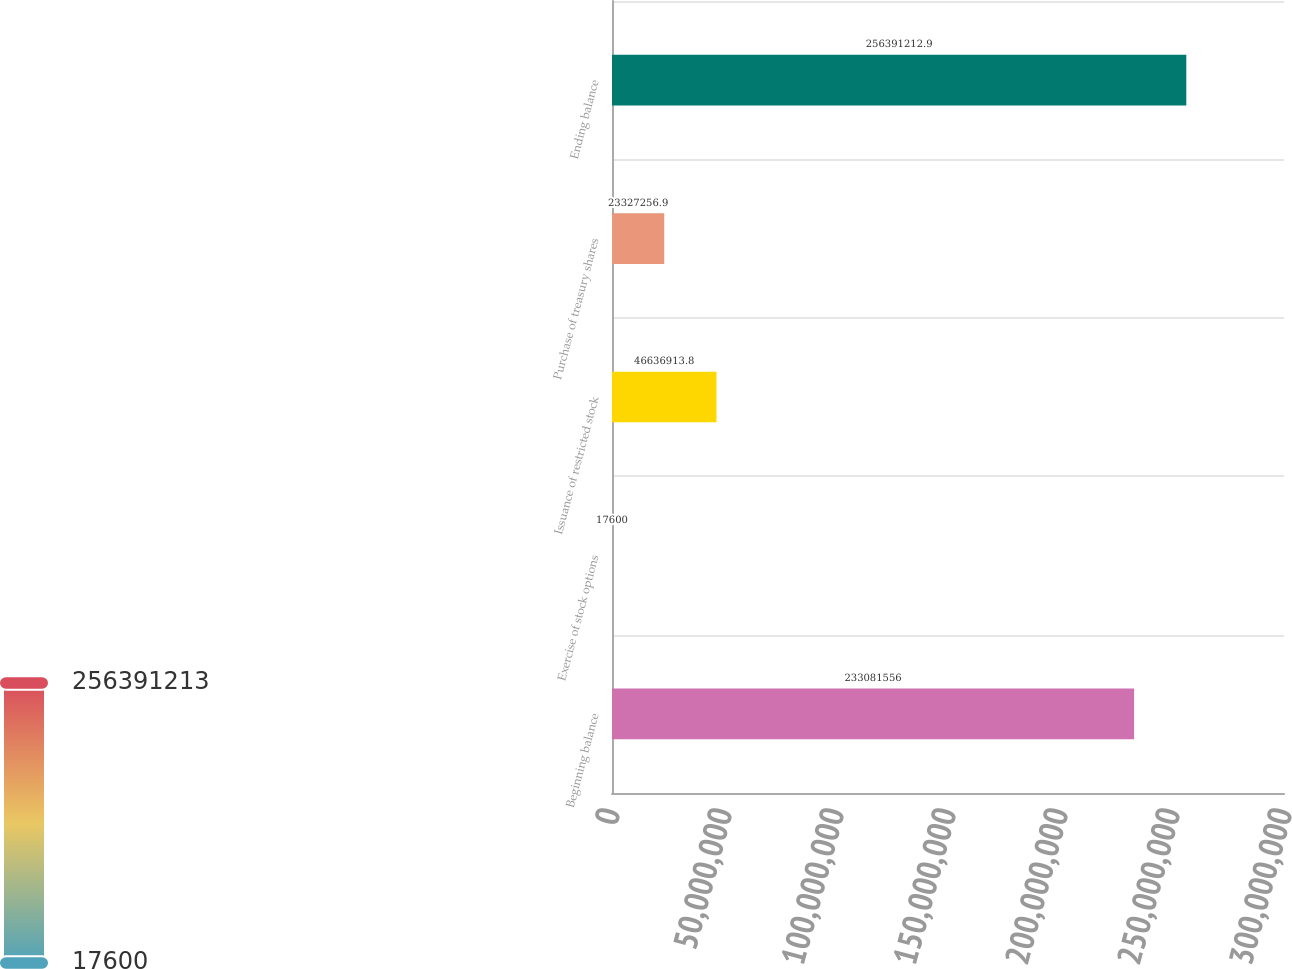Convert chart. <chart><loc_0><loc_0><loc_500><loc_500><bar_chart><fcel>Beginning balance<fcel>Exercise of stock options<fcel>Issuance of restricted stock<fcel>Purchase of treasury shares<fcel>Ending balance<nl><fcel>2.33082e+08<fcel>17600<fcel>4.66369e+07<fcel>2.33273e+07<fcel>2.56391e+08<nl></chart> 